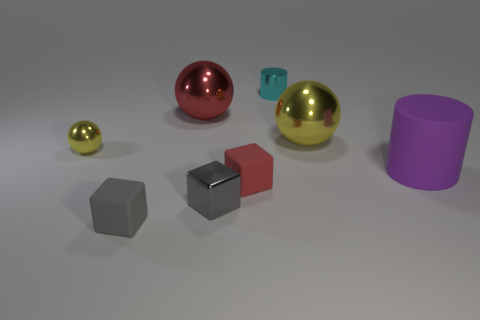Add 1 small green rubber cylinders. How many objects exist? 9 Subtract all yellow spheres. How many spheres are left? 1 Subtract 2 balls. How many balls are left? 1 Subtract all green blocks. How many yellow spheres are left? 2 Subtract all cyan cylinders. How many cylinders are left? 1 Subtract all blocks. How many objects are left? 5 Subtract 0 cyan cubes. How many objects are left? 8 Subtract all blue balls. Subtract all brown blocks. How many balls are left? 3 Subtract all large rubber cylinders. Subtract all purple objects. How many objects are left? 6 Add 8 big red spheres. How many big red spheres are left? 9 